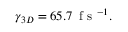Convert formula to latex. <formula><loc_0><loc_0><loc_500><loc_500>\gamma _ { 3 D } = 6 5 . 7 \, f s ^ { - 1 } .</formula> 